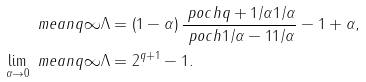<formula> <loc_0><loc_0><loc_500><loc_500>\ m e a n q { \infty } { \Lambda } & = \left ( 1 - \alpha \right ) \frac { \ p o c h { q + 1 / \alpha } { 1 / \alpha } } { \ p o c h { 1 / \alpha - 1 } { 1 / \alpha } } - 1 + \alpha , \\ \lim _ { \alpha \to 0 } \ m e a n q { \infty } { \Lambda } & = 2 ^ { q + 1 } - 1 .</formula> 